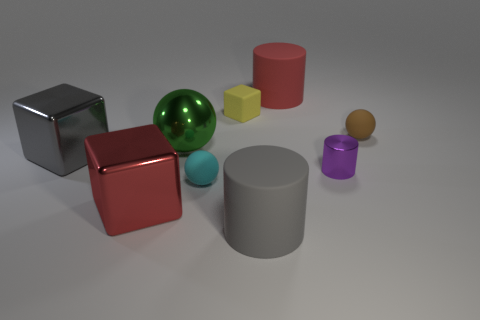Subtract all rubber spheres. How many spheres are left? 1 Add 1 large cyan balls. How many objects exist? 10 Subtract all cylinders. How many objects are left? 6 Subtract all cyan cylinders. Subtract all cubes. How many objects are left? 6 Add 1 large red rubber cylinders. How many large red rubber cylinders are left? 2 Add 8 red blocks. How many red blocks exist? 9 Subtract 0 red balls. How many objects are left? 9 